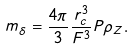Convert formula to latex. <formula><loc_0><loc_0><loc_500><loc_500>m _ { \delta } = \frac { 4 \pi } { 3 } \frac { r _ { c } ^ { 3 } } { F ^ { 3 } } P \rho _ { Z } .</formula> 